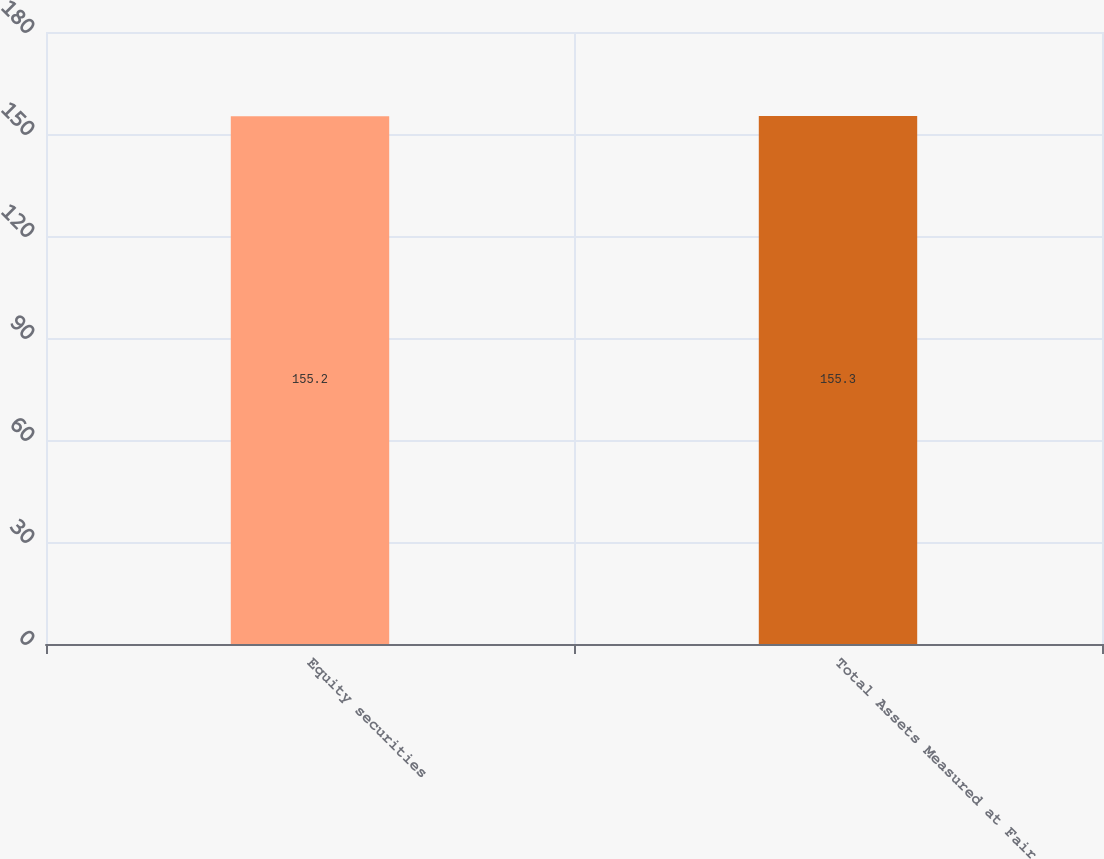Convert chart to OTSL. <chart><loc_0><loc_0><loc_500><loc_500><bar_chart><fcel>Equity securities<fcel>Total Assets Measured at Fair<nl><fcel>155.2<fcel>155.3<nl></chart> 